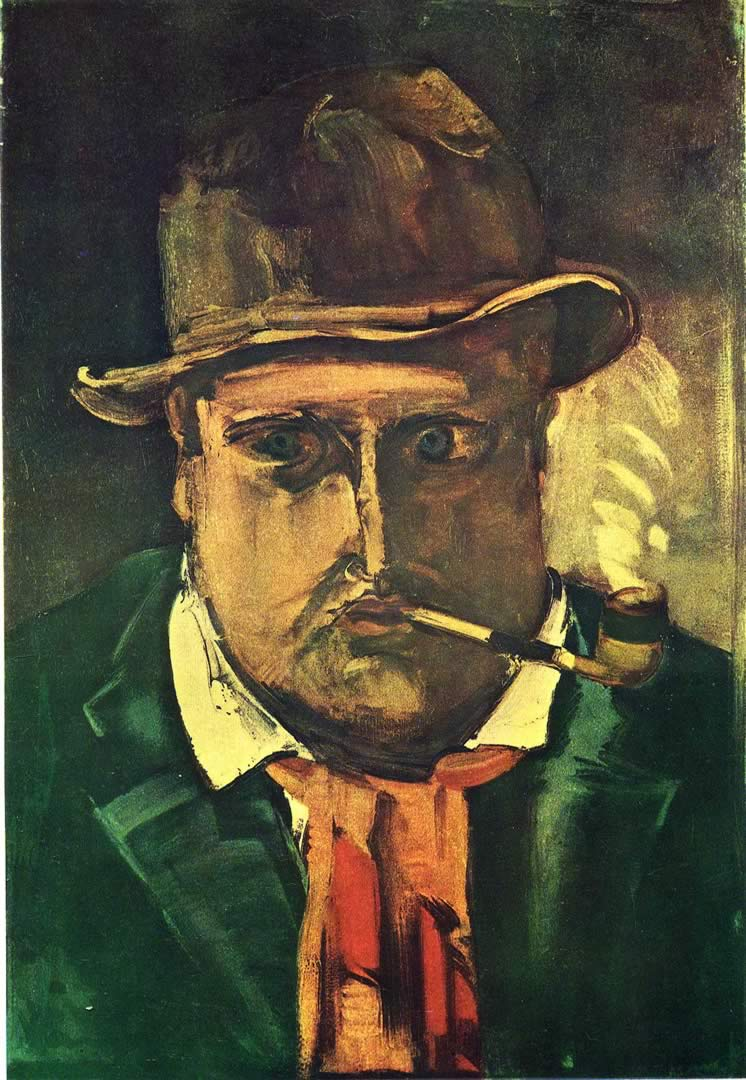Can you describe the main features of this image for me? The image is an expressionist oil painting showcasing a man wearing a hat and smoking a pipe, characterized by a moody dark green and brown palette with touches of vibrant red and yellow. The painting’s style, with pronounced distortion and exaggeration in the depiction of the man’s facial features and attire, typifies expressionist techniques used to convey emotional experiences rather than physical reality. This piece could be dated back to the early 20th century, reflecting the height of expressionism, where artists focused on portraying subjective emotions over realistic portrayals. This artwork invokes a sense of introspection and could be seen as exploring themes of isolation or contemplation. 